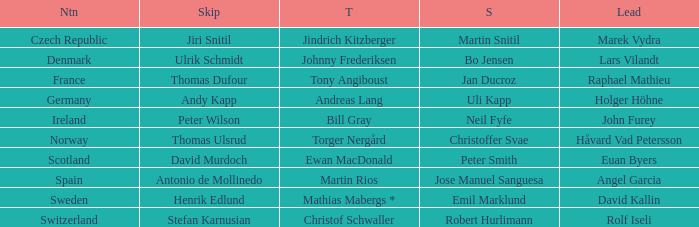The nation of scotland is located in which third? Ewan MacDonald. 